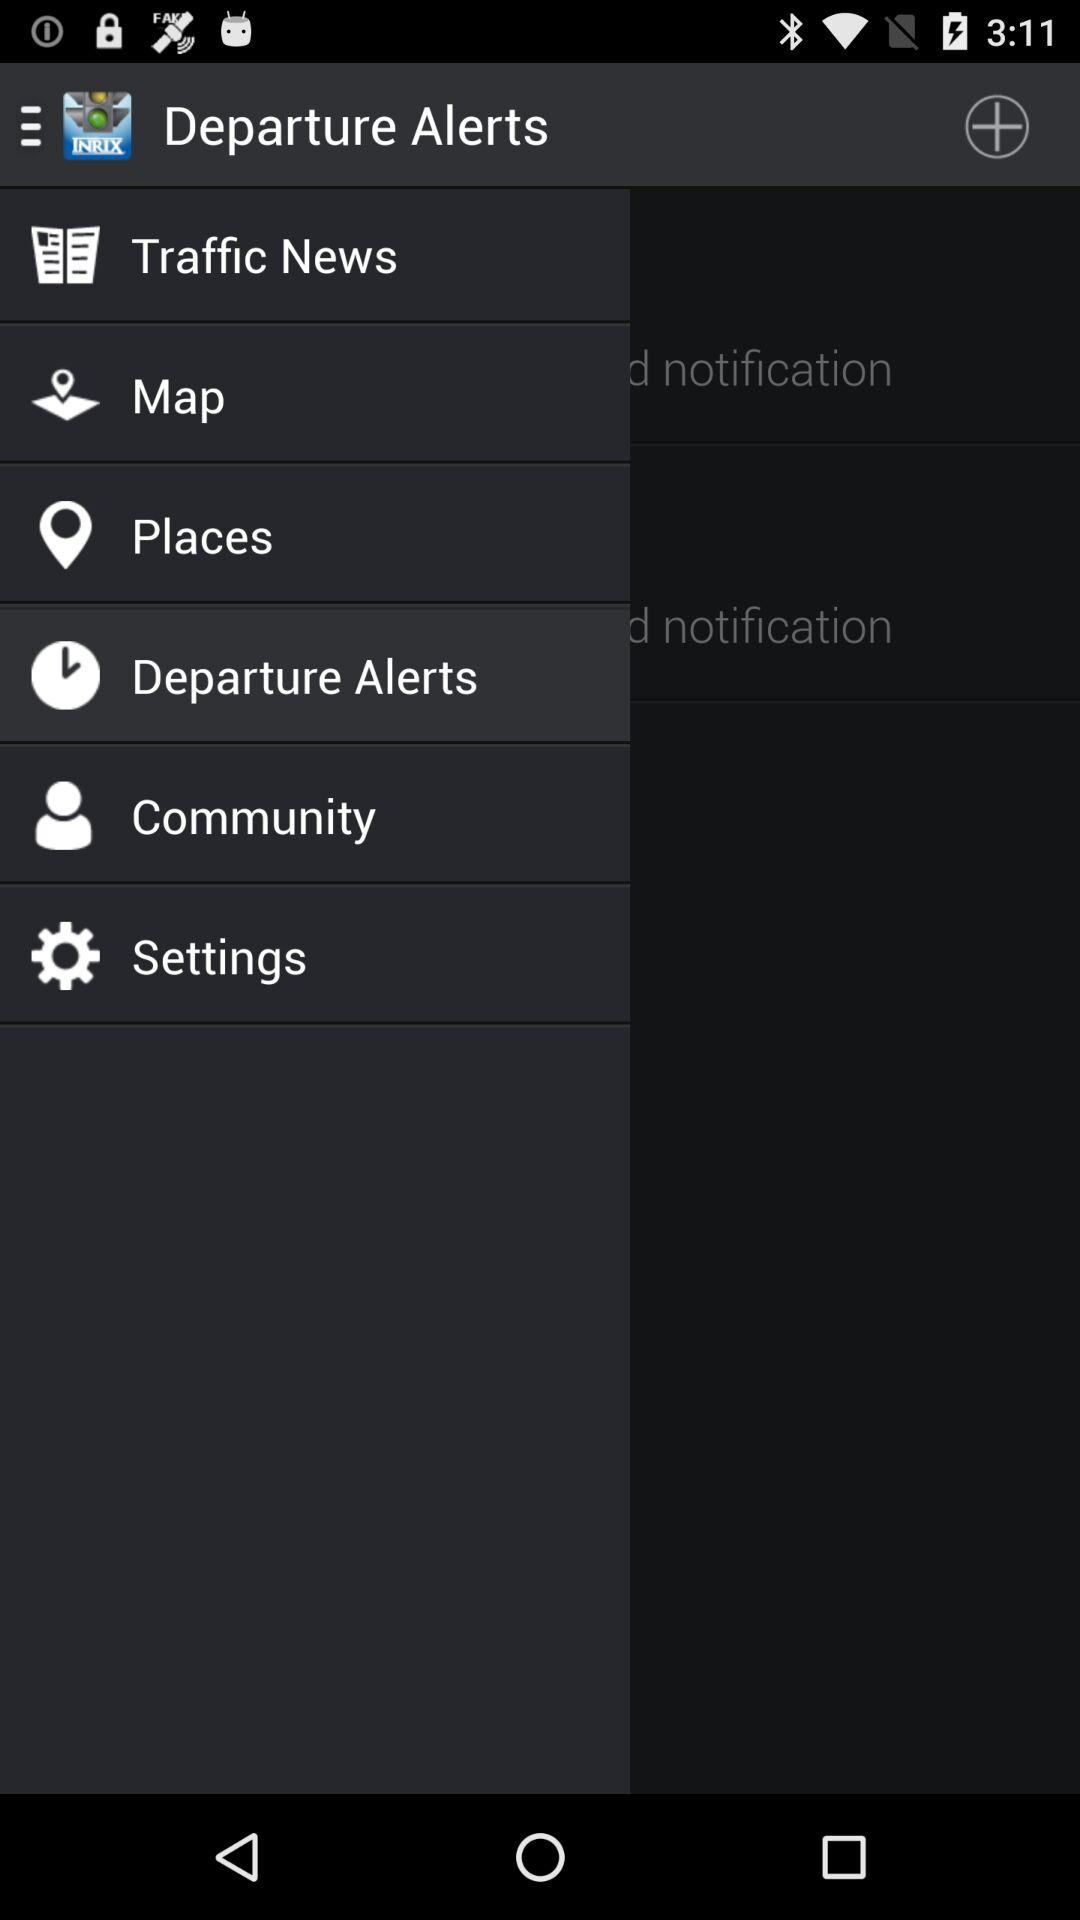How many notifications are there?
Answer the question using a single word or phrase. 2 